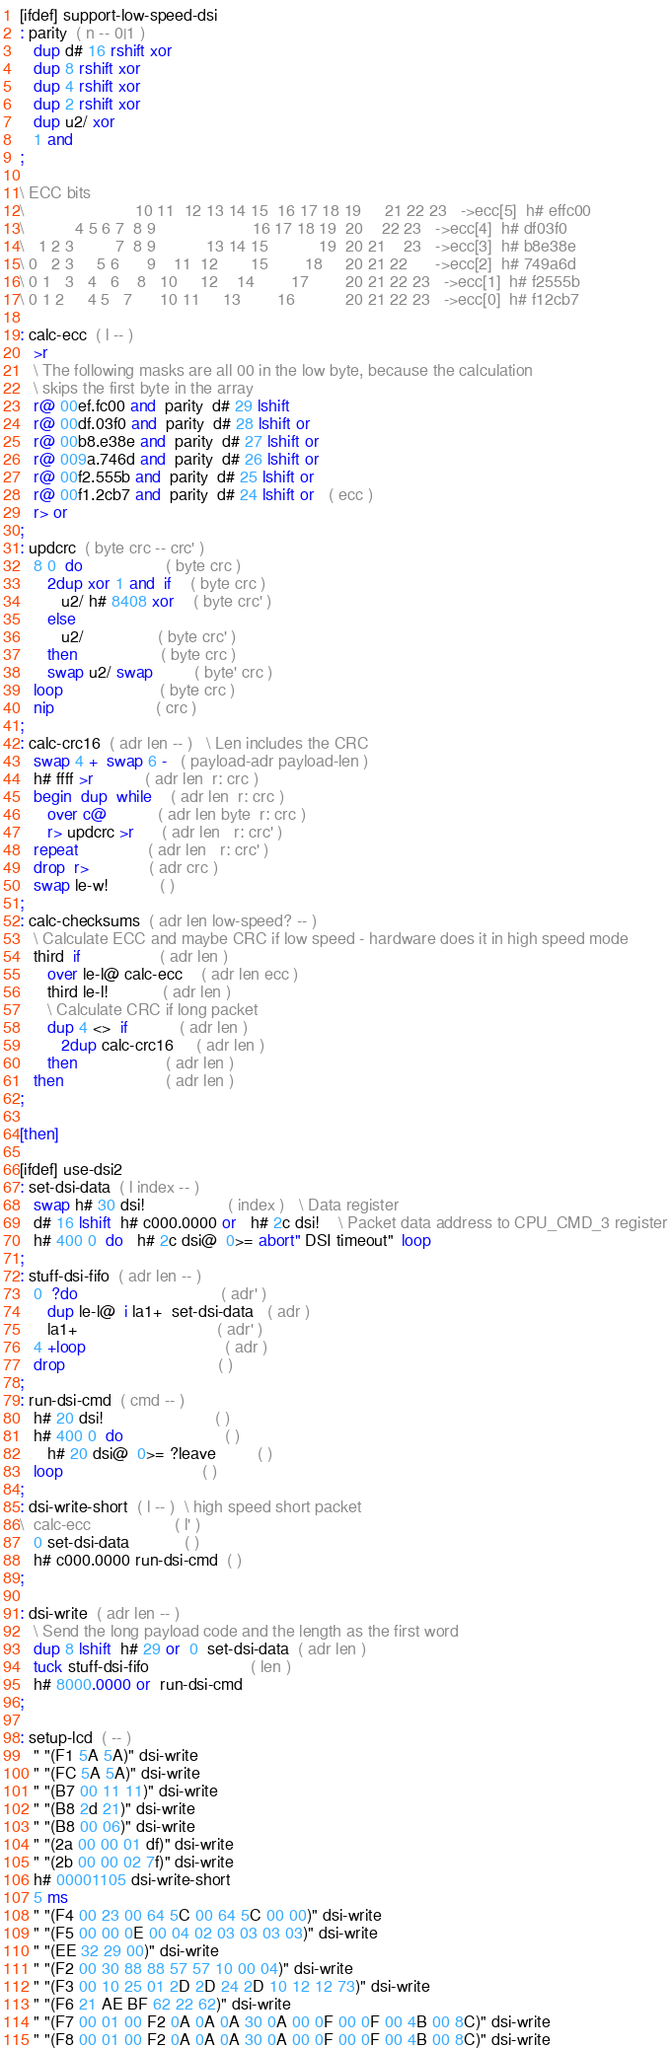Convert code to text. <code><loc_0><loc_0><loc_500><loc_500><_Forth_>
[ifdef] support-low-speed-dsi
: parity  ( n -- 0|1 )
   dup d# 16 rshift xor
   dup 8 rshift xor
   dup 4 rshift xor
   dup 2 rshift xor
   dup u2/ xor
   1 and
;

\ ECC bits
\                        10 11  12 13 14 15  16 17 18 19     21 22 23   ->ecc[5]  h# effc00
\           4 5 6 7  8 9                     16 17 18 19  20    22 23   ->ecc[4]  h# df03f0
\   1 2 3         7  8 9           13 14 15           19  20 21    23   ->ecc[3]  h# b8e38e
\ 0   2 3     5 6      9    11  12       15        18     20 21 22      ->ecc[2]  h# 749a6d
\ 0 1   3   4   6    8   10     12    14        17        20 21 22 23   ->ecc[1]  h# f2555b
\ 0 1 2     4 5   7      10 11     13        16           20 21 22 23   ->ecc[0]  h# f12cb7

: calc-ecc  ( l -- )
   >r
   \ The following masks are all 00 in the low byte, because the calculation
   \ skips the first byte in the array
   r@ 00ef.fc00 and  parity  d# 29 lshift
   r@ 00df.03f0 and  parity  d# 28 lshift or
   r@ 00b8.e38e and  parity  d# 27 lshift or
   r@ 009a.746d and  parity  d# 26 lshift or
   r@ 00f2.555b and  parity  d# 25 lshift or
   r@ 00f1.2cb7 and  parity  d# 24 lshift or   ( ecc )
   r> or
;
: updcrc  ( byte crc -- crc' )
   8 0  do                  ( byte crc )
      2dup xor 1 and  if    ( byte crc )
         u2/ h# 8408 xor    ( byte crc' )
      else  
         u2/                ( byte crc' )
      then                  ( byte crc )
      swap u2/ swap         ( byte' crc )
   loop                     ( byte crc )
   nip                      ( crc )
;
: calc-crc16  ( adr len -- )   \ Len includes the CRC
   swap 4 +  swap 6 -   ( payload-adr payload-len )
   h# ffff >r           ( adr len  r: crc )
   begin  dup  while    ( adr len  r: crc )
      over c@           ( adr len byte  r: crc )
      r> updcrc >r      ( adr len   r: crc' )
   repeat               ( adr len   r: crc' )
   drop  r>             ( adr crc )
   swap le-w!           ( )
;
: calc-checksums  ( adr len low-speed? -- )
   \ Calculate ECC and maybe CRC if low speed - hardware does it in high speed mode
   third  if                 ( adr len )
      over le-l@ calc-ecc    ( adr len ecc )
      third le-l!            ( adr len )
      \ Calculate CRC if long packet
      dup 4 <>  if           ( adr len )
         2dup calc-crc16     ( adr len )
      then                   ( adr len )
   then                      ( adr len )
;

[then]

[ifdef] use-dsi2
: set-dsi-data  ( l index -- )
   swap h# 30 dsi!                  ( index )   \ Data register
   d# 16 lshift  h# c000.0000 or   h# 2c dsi!    \ Packet data address to CPU_CMD_3 register
   h# 400 0  do   h# 2c dsi@  0>= abort" DSI timeout"  loop
;
: stuff-dsi-fifo  ( adr len -- )
   0  ?do                               ( adr' )
      dup le-l@  i la1+  set-dsi-data   ( adr )
      la1+                              ( adr' )
   4 +loop                              ( adr )
   drop                                 ( )
;
: run-dsi-cmd  ( cmd -- )
   h# 20 dsi!                        ( )
   h# 400 0  do                      ( )
      h# 20 dsi@  0>= ?leave         ( )
   loop                              ( )
;
: dsi-write-short  ( l -- )  \ high speed short packet
\  calc-ecc                  ( l' )
   0 set-dsi-data            ( )
   h# c000.0000 run-dsi-cmd  ( )
;

: dsi-write  ( adr len -- )
   \ Send the long payload code and the length as the first word
   dup 8 lshift  h# 29 or  0  set-dsi-data  ( adr len )
   tuck stuff-dsi-fifo                      ( len )
   h# 8000.0000 or  run-dsi-cmd
;

: setup-lcd  ( -- )
   " "(F1 5A 5A)" dsi-write
   " "(FC 5A 5A)" dsi-write
   " "(B7 00 11 11)" dsi-write
   " "(B8 2d 21)" dsi-write
   " "(B8 00 06)" dsi-write
   " "(2a 00 00 01 df)" dsi-write
   " "(2b 00 00 02 7f)" dsi-write
   h# 00001105 dsi-write-short
   5 ms
   " "(F4 00 23 00 64 5C 00 64 5C 00 00)" dsi-write
   " "(F5 00 00 0E 00 04 02 03 03 03 03)" dsi-write
   " "(EE 32 29 00)" dsi-write
   " "(F2 00 30 88 88 57 57 10 00 04)" dsi-write
   " "(F3 00 10 25 01 2D 2D 24 2D 10 12 12 73)" dsi-write
   " "(F6 21 AE BF 62 22 62)" dsi-write
   " "(F7 00 01 00 F2 0A 0A 0A 30 0A 00 0F 00 0F 00 4B 00 8C)" dsi-write
   " "(F8 00 01 00 F2 0A 0A 0A 30 0A 00 0F 00 0F 00 4B 00 8C)" dsi-write</code> 